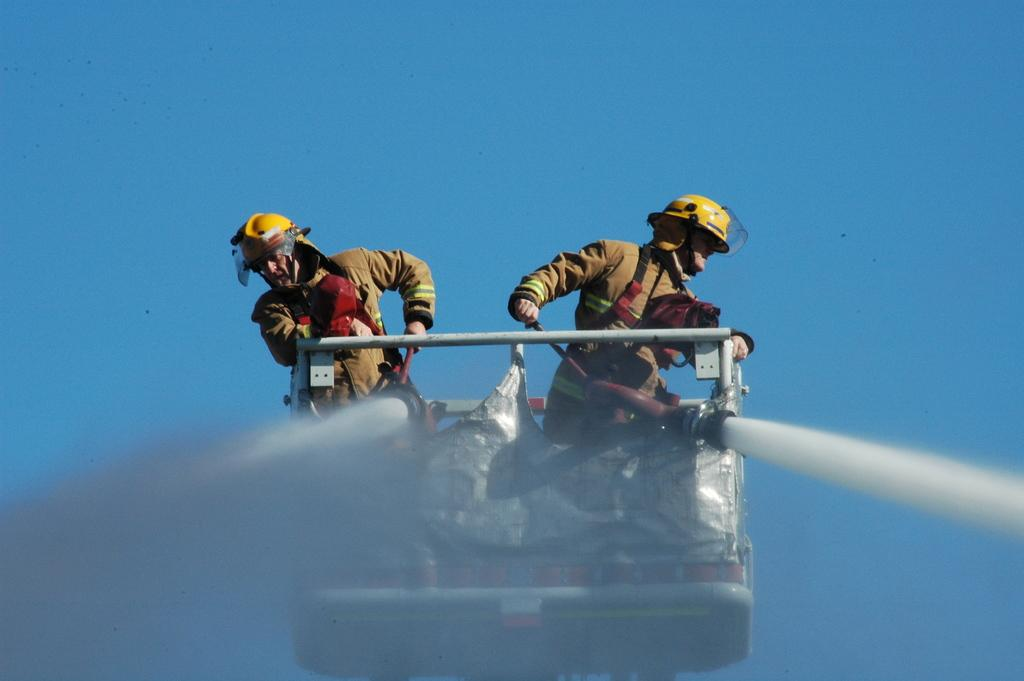What are the people in the image wearing on their heads? The people in the image are wearing helmets. What type of equipment can be seen in the image? There are water pipes in the image. What can be seen in the background of the image? The sky is visible in the background of the image. What texture does the eye of the person in the image have? There is no eye visible in the image, as the people are wearing helmets that cover their faces. 